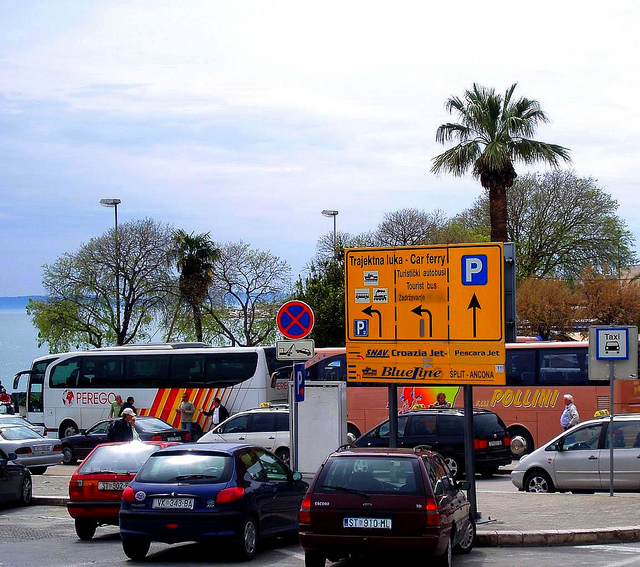<image>What route is on the blue street sign? I am not sure what route is on the blue street sign. It could be a taxi, bus route, parking, or none. What route is on the blue street sign? I don't know what route is on the blue street sign. It can be either taxi, parking, bus route, no route, east, none, or fun. 